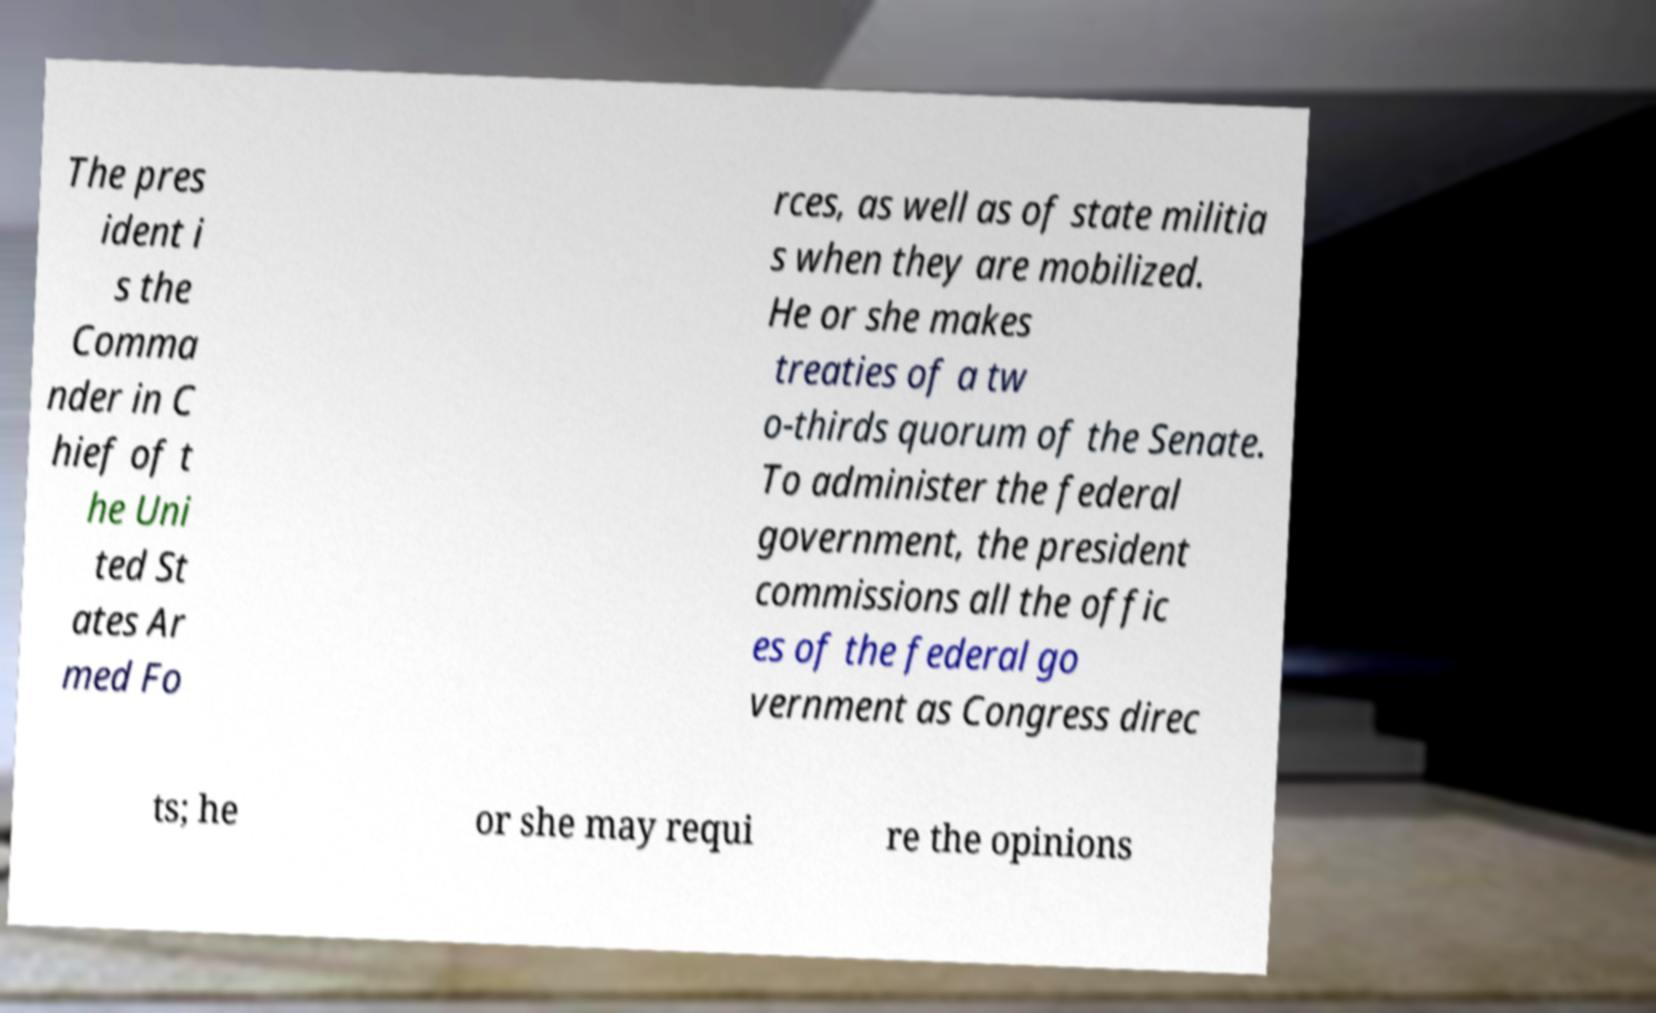What messages or text are displayed in this image? I need them in a readable, typed format. The pres ident i s the Comma nder in C hief of t he Uni ted St ates Ar med Fo rces, as well as of state militia s when they are mobilized. He or she makes treaties of a tw o-thirds quorum of the Senate. To administer the federal government, the president commissions all the offic es of the federal go vernment as Congress direc ts; he or she may requi re the opinions 